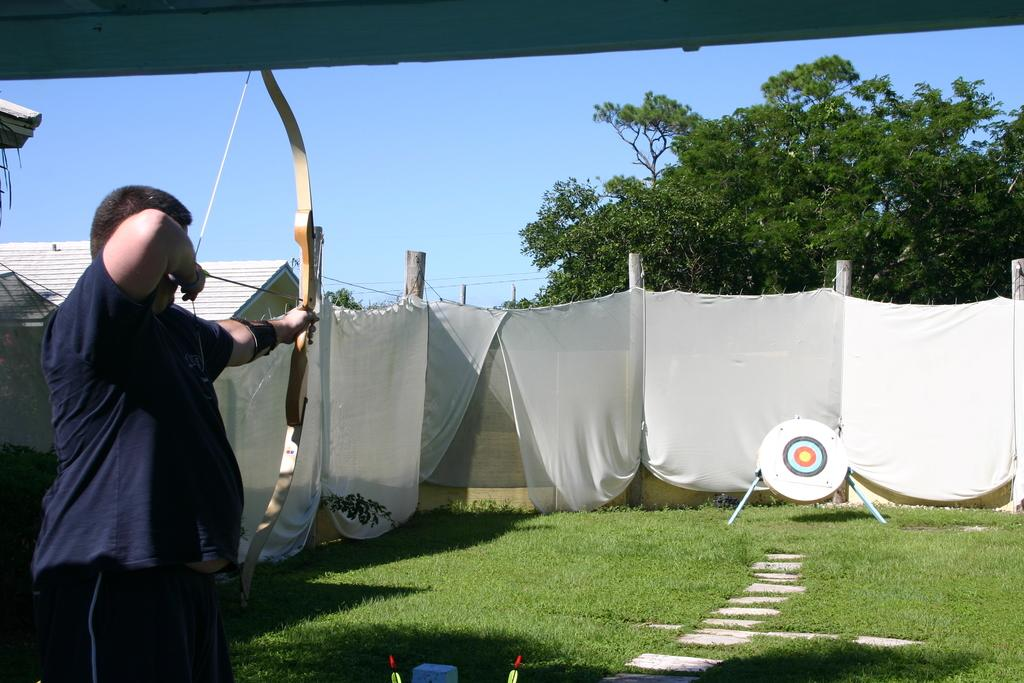What color are the clothes in the image? The clothes in the image are white. What type of vegetation can be seen in the image? There is grass and trees in the image. What part of the natural environment is visible in the image? The sky is visible in the image. What type of structure is present in the image? There is a house in the image. Who is present in the image? There is a person in the image. What color is the person's t-shirt? The person is wearing a blue color t-shirt. What is the person holding in the image? The person is holding a bow. Where is the marble tray located in the image? There is no marble tray present in the image. Can you describe the monkey's behavior in the image? There is no monkey present in the image. 